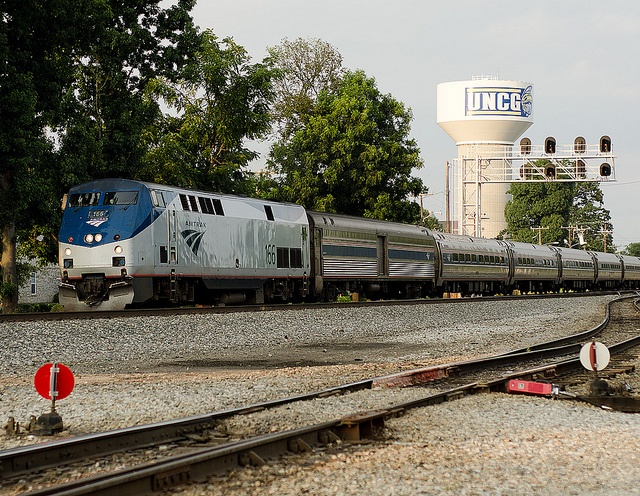<image>Where is this train going? It is uncertain where the train is going. It could be going toward the camera, downtown, straight, to the station, south, or to the city. Where is this train going? I don't know where this train is going. It can be going west, downtown, to the station, or anywhere else. 